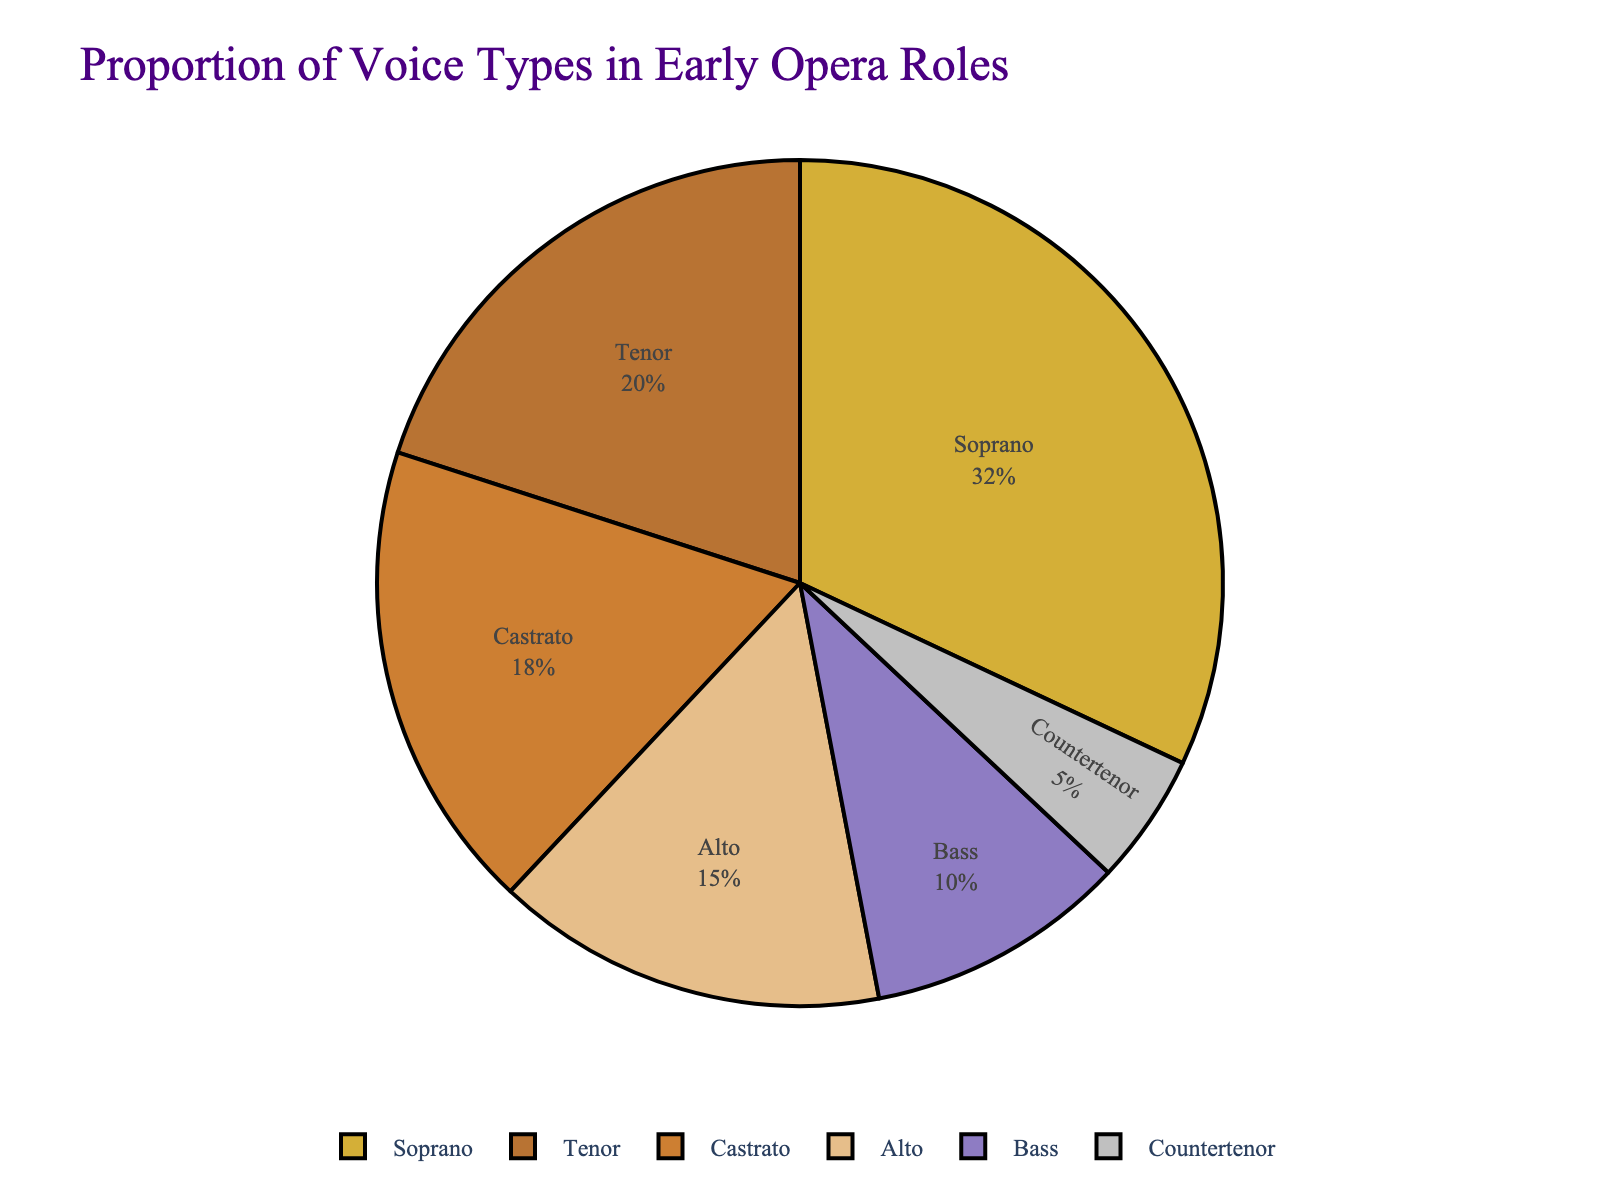Which voice type has the highest proportion of roles in early opera? The voice type with the largest segment in the pie chart represents the highest proportion. The Soprano segment is the largest.
Answer: Soprano What is the combined percentage of roles for Castrato and Alto? Add the percentage for Castrato (18%) to that of Alto (15%). This gives 18 + 15 = 33%.
Answer: 33% Which voice type has a higher proportion of roles in early opera, Tenor or Bass? Compare the sizes of the Tenor (20%) segment and the Bass (10%) segment. The Tenor percentage is greater.
Answer: Tenor How much larger is the proportion of Soprano roles compared to Countertenor roles? Subtract the percentage of Countertenor (5%) from the percentage of Soprano (32%). This gives 32 - 5 = 27%.
Answer: 27% What is the total percentage of roles accounted for by Soprano, Alto, and Tenor? Add the percentages of Soprano (32%), Alto (15%), and Tenor (20%). This gives 32 + 15 + 20 = 67%.
Answer: 67% What percentage of roles are taken by voice types other than Soprano and Tenor? Subtract the combined percentage of Soprano (32%) and Tenor (20%) from 100%. This gives 100 - 32 - 20 = 48%.
Answer: 48% Which voice type has the smallest proportion of roles in early opera? Identify the smallest segment in the pie chart, which is the Countertenor segment at 5%.
Answer: Countertenor If you sum up the proportions of Castrato and Bass roles, do they exceed 25%? Add the percentages for Castrato (18%) and Bass (10%). This gives 18 + 10 = 28%, which is greater than 25%.
Answer: Yes What is the difference in proportion between Alto and Countertenor roles? Subtract the percentage of Countertenor (5%) from the percentage of Alto (15%). This gives 15 - 5 = 10%.
Answer: 10% Which voice types together represent more than half of the roles in early opera? Sum the highest percentage roles until the total exceeds 50%. Soprano (32%) + Tenor (20%) = 52%, exceeding half.
Answer: Soprano and Tenor 